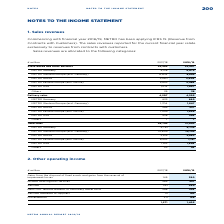According to Metro Ag's financial document, When has METRO started applying IFRS 15? Commencing with financial year 2018/19. The document states: "Commencing with financial year 2018/19, METRO has been applying IFRS 15 (Revenue from..." Also, What do to the sales revenues reported for the current financial year relate to? relate exclusively to revenues from contracts with customers. The document states: "revenues reported for the current financial year relate exclusively to revenues from contracts with customers...." Also, What are the categories of sales revenue allocations in the table? The document contains multiple relevant values: Store-based and other business, Delivery sales, Total sales. From the document: "Delivery sales 4,207 4,595 Total sales 26,792 27,082 Store-based and other business 22,585 22,487..." Additionally, In which year was the Total sales larger? Based on the financial document, the answer is 2018/2019. Also, can you calculate: What was the change in Delivery sales in 2018/2019 from 2017/2018? Based on the calculation: 4,595-4,207, the result is 388 (in millions). This is based on the information: "Delivery sales 4,207 4,595 Delivery sales 4,207 4,595..." The key data points involved are: 4,207, 4,595. Also, can you calculate: What was the percentage change in Delivery sales in 2018/2019 from 2017/2018? To answer this question, I need to perform calculations using the financial data. The calculation is: (4,595-4,207)/4,207, which equals 9.22 (percentage). This is based on the information: "Delivery sales 4,207 4,595 Delivery sales 4,207 4,595..." The key data points involved are: 4,207, 4,595. 